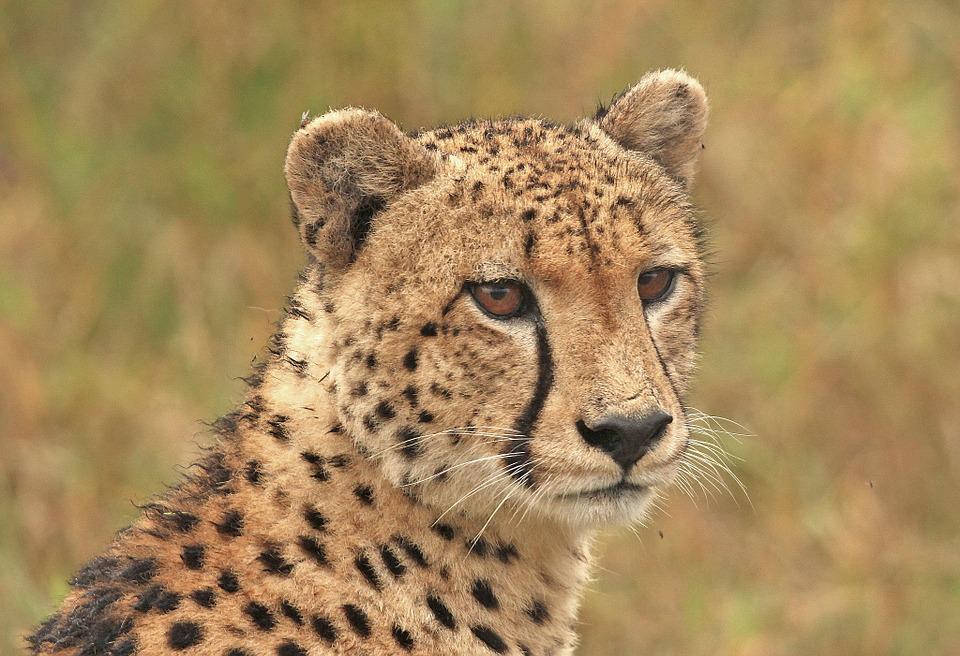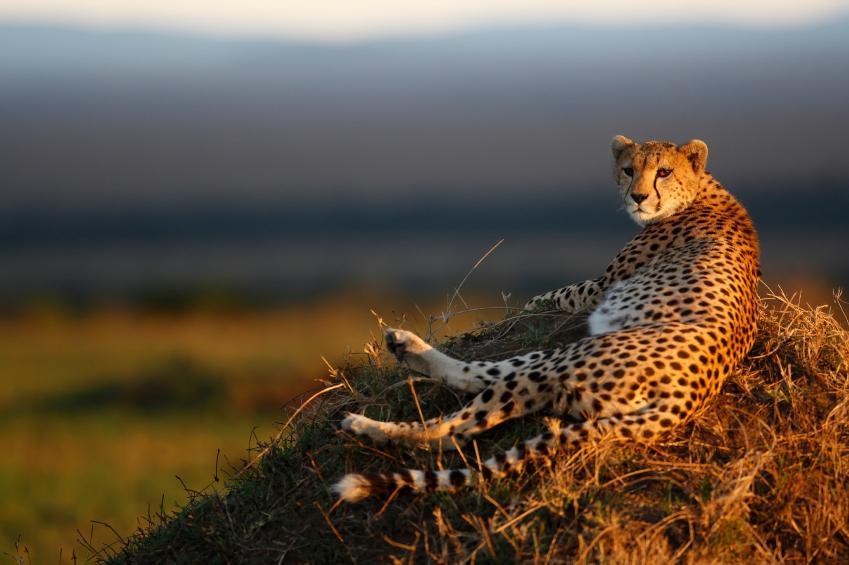The first image is the image on the left, the second image is the image on the right. Considering the images on both sides, is "In one of the images there is a leopard lying on the ground." valid? Answer yes or no. Yes. 